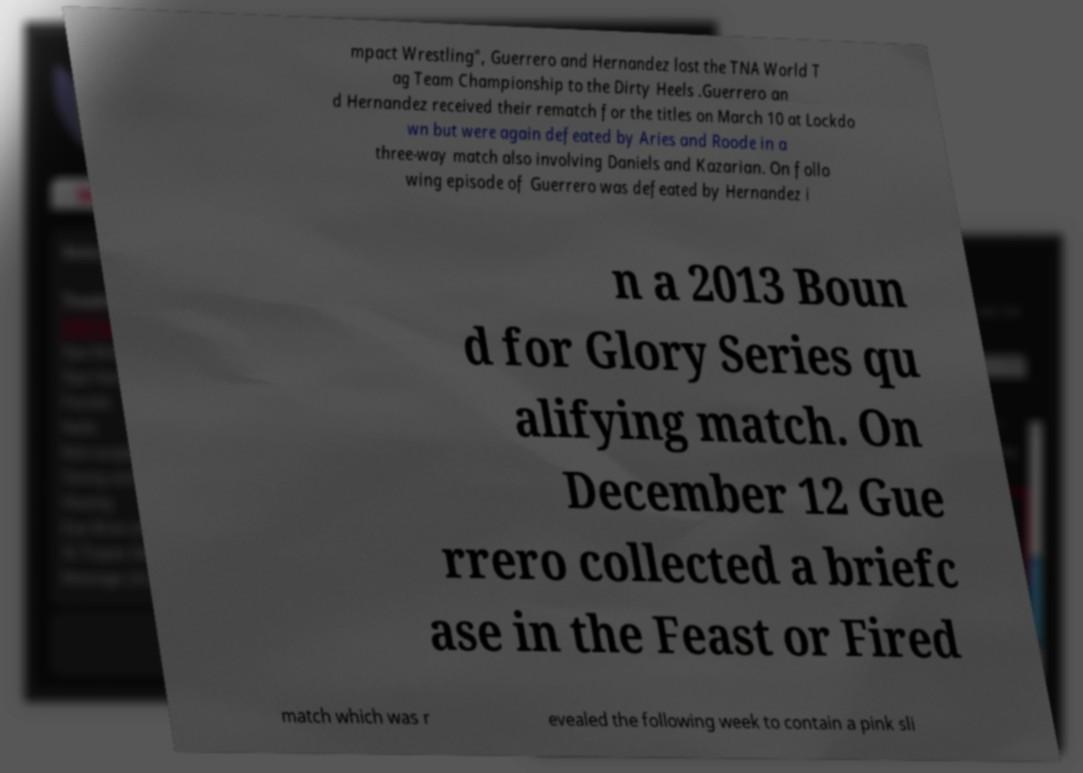Could you extract and type out the text from this image? mpact Wrestling", Guerrero and Hernandez lost the TNA World T ag Team Championship to the Dirty Heels .Guerrero an d Hernandez received their rematch for the titles on March 10 at Lockdo wn but were again defeated by Aries and Roode in a three-way match also involving Daniels and Kazarian. On follo wing episode of Guerrero was defeated by Hernandez i n a 2013 Boun d for Glory Series qu alifying match. On December 12 Gue rrero collected a briefc ase in the Feast or Fired match which was r evealed the following week to contain a pink sli 